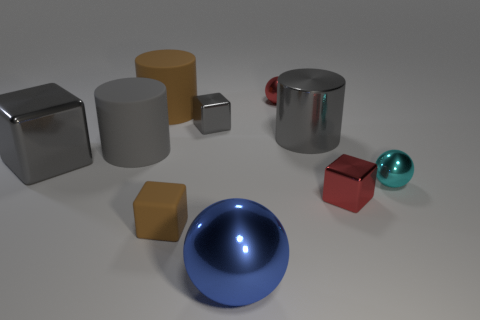What can you infer about the lighting in this scene? The lighting in the scene is well-balanced and seems to come from above, as indicated by the soft shadows directly underneath the objects. The highlights on the glossy and metallic surfaces suggest a single, possibly diffused, light source that creates a gentle illumination across the scene without harsh contrasts. 